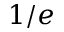<formula> <loc_0><loc_0><loc_500><loc_500>1 / e</formula> 